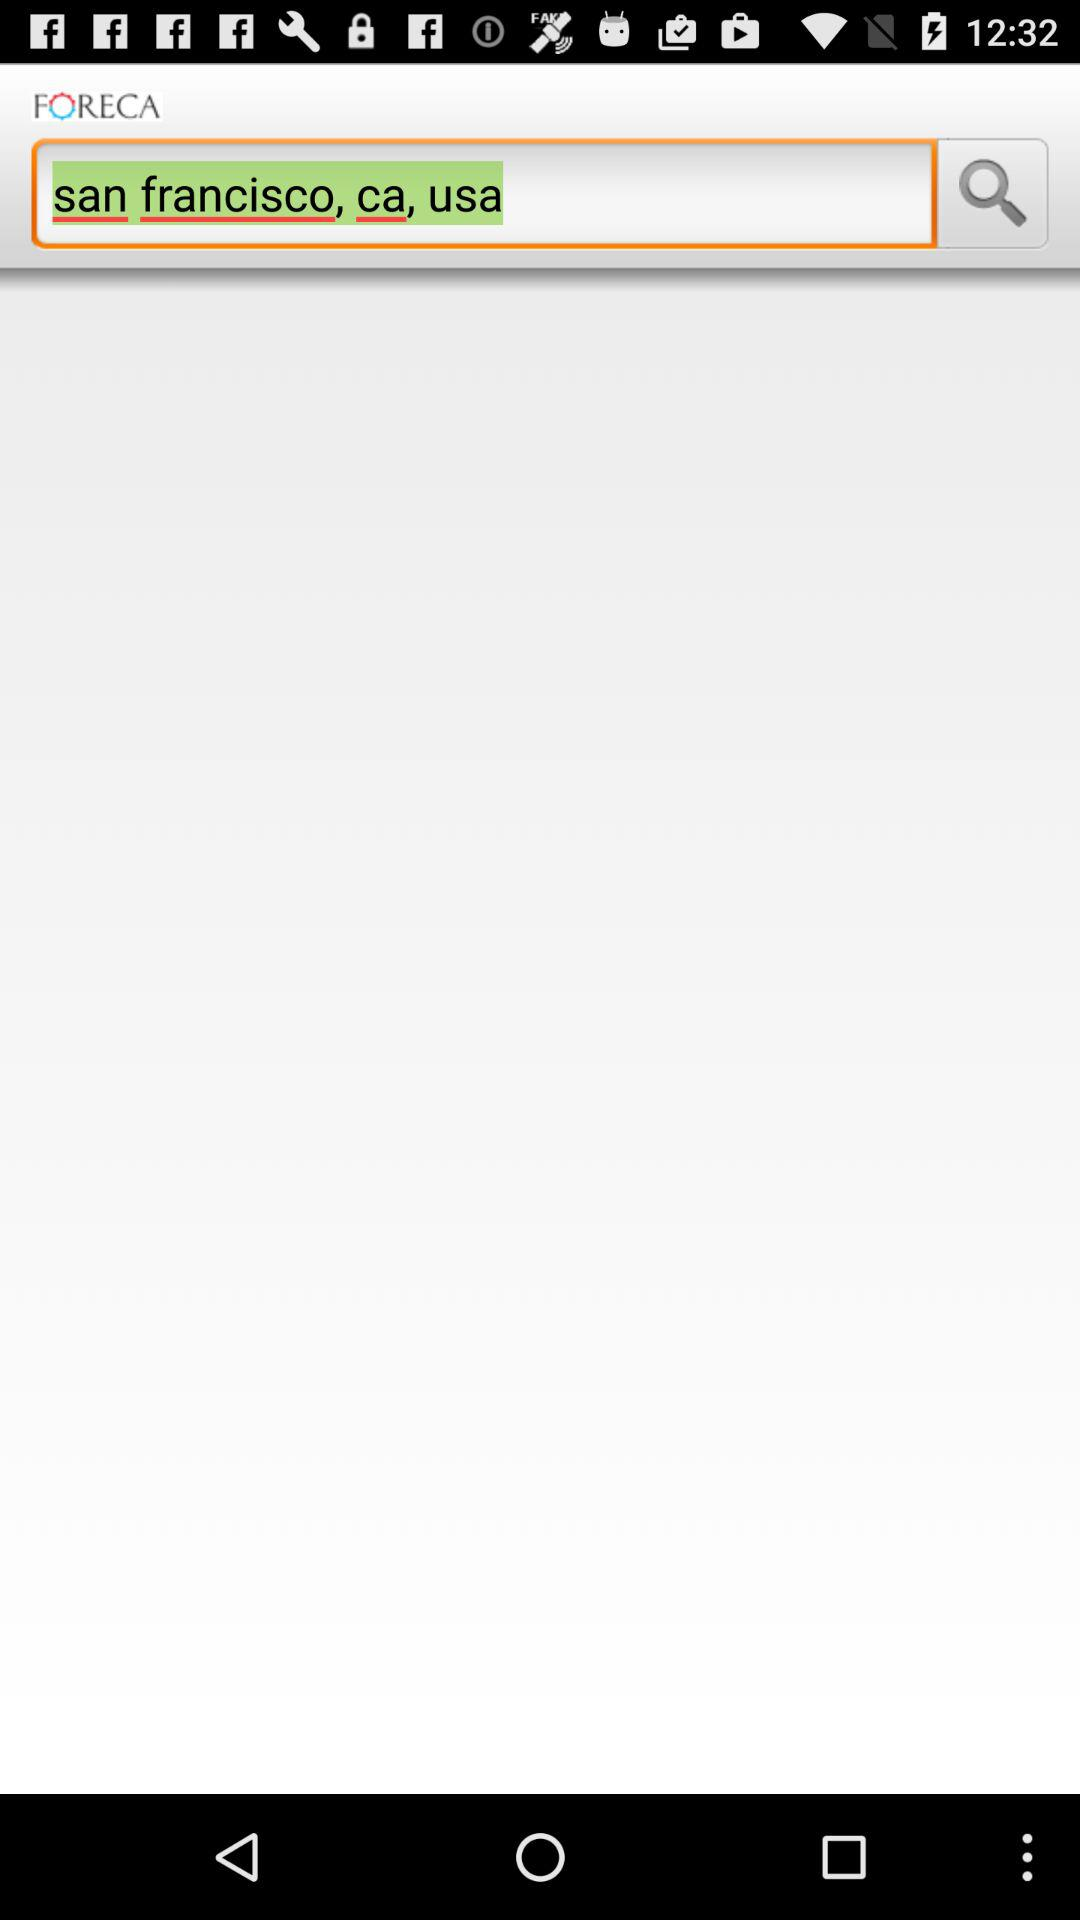What is the version of this application?
When the provided information is insufficient, respond with <no answer>. <no answer> 